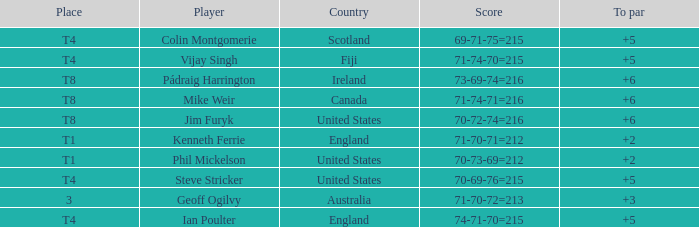What score to par did Mike Weir have? 6.0. 